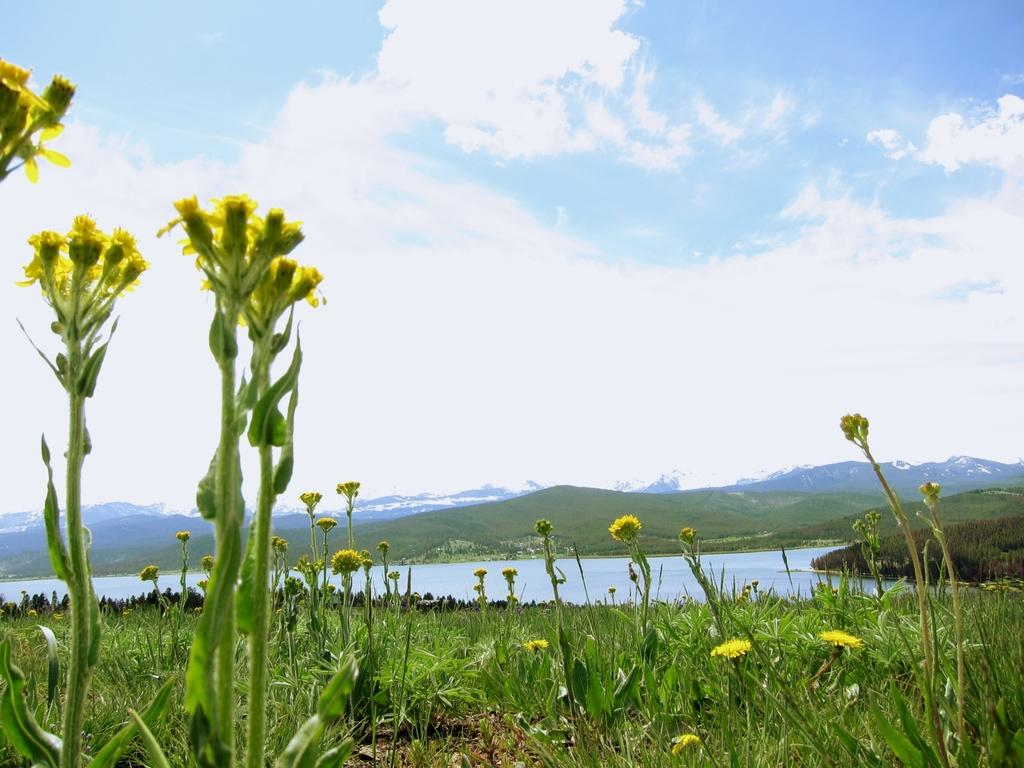What types of vegetation are at the bottom of the image? There are plants and flowers at the bottom of the image. What can be seen in the background of the image? There is a lake and mountains in the background of the image. What is visible at the top of the image? The sky is visible at the top of the image. How many cats are sitting on the cork in the image? There are no cats or cork present in the image. What is the arm doing in the image? There is no arm present in the image. 